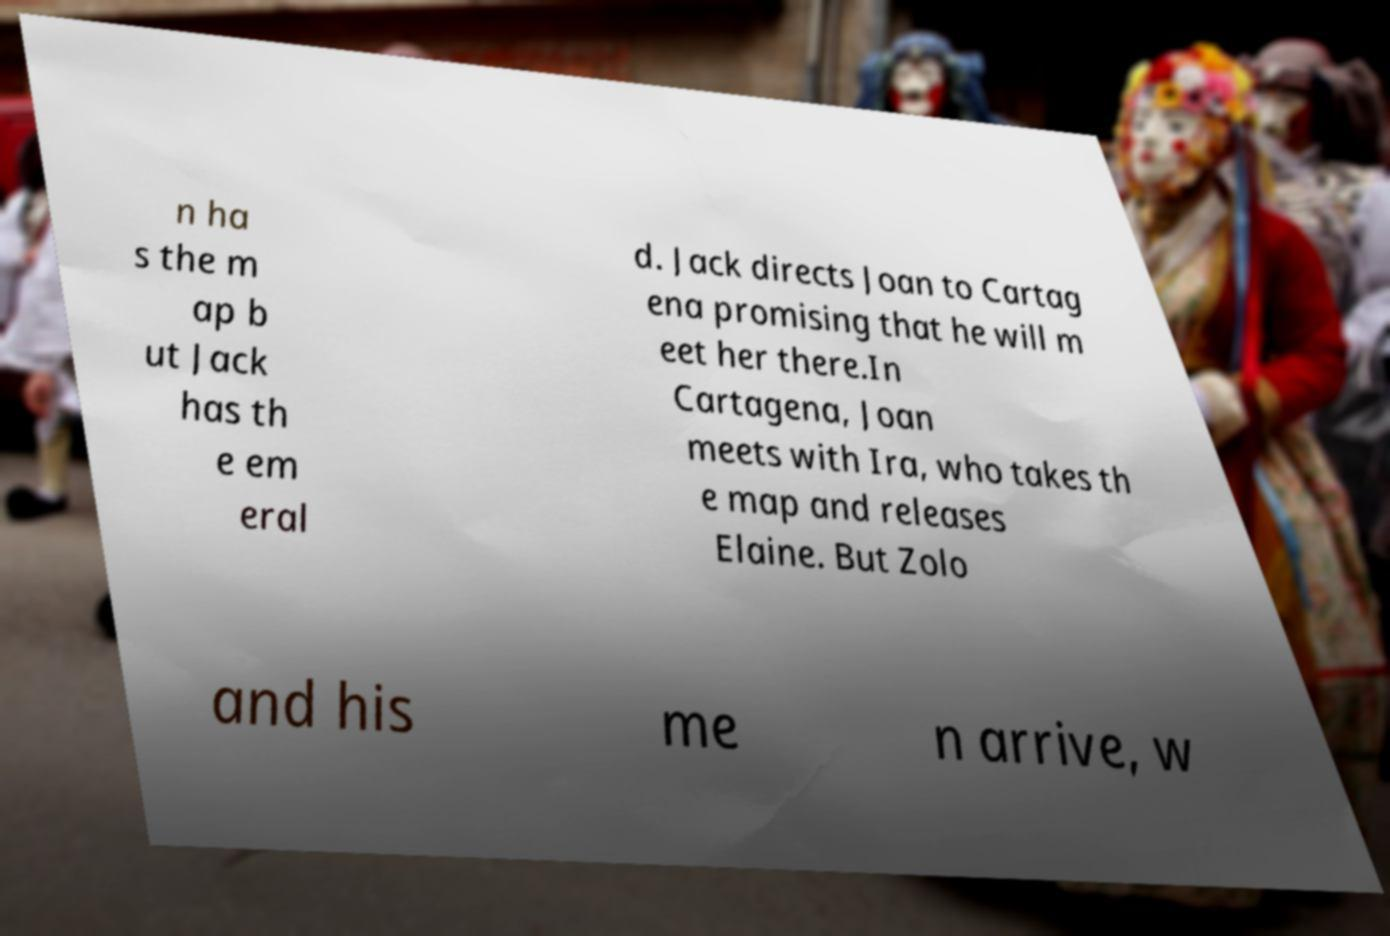Could you extract and type out the text from this image? n ha s the m ap b ut Jack has th e em eral d. Jack directs Joan to Cartag ena promising that he will m eet her there.In Cartagena, Joan meets with Ira, who takes th e map and releases Elaine. But Zolo and his me n arrive, w 